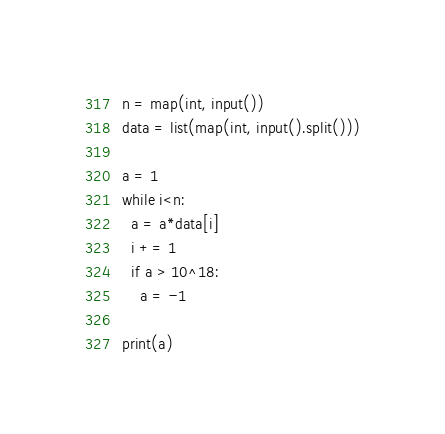Convert code to text. <code><loc_0><loc_0><loc_500><loc_500><_Python_>n = map(int, input())
data = list(map(int, input().split()))

a = 1
while i<n:
  a = a*data[i]
  i += 1
  if a > 10^18:
    a = -1

print(a)</code> 